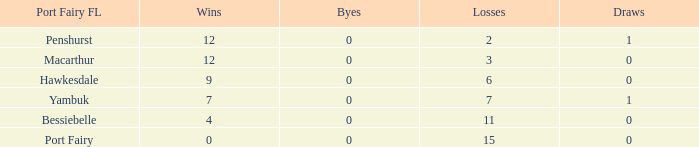How many wins for Port Fairy and against more than 2333? None. 